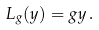Convert formula to latex. <formula><loc_0><loc_0><loc_500><loc_500>L _ { g } ( y ) = g y \, .</formula> 